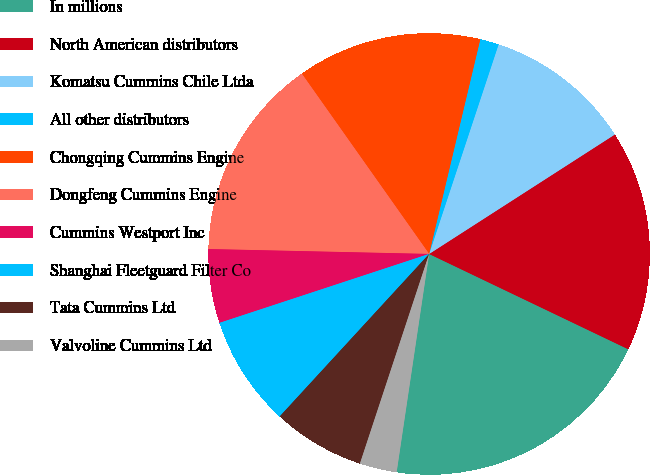Convert chart to OTSL. <chart><loc_0><loc_0><loc_500><loc_500><pie_chart><fcel>In millions<fcel>North American distributors<fcel>Komatsu Cummins Chile Ltda<fcel>All other distributors<fcel>Chongqing Cummins Engine<fcel>Dongfeng Cummins Engine<fcel>Cummins Westport Inc<fcel>Shanghai Fleetguard Filter Co<fcel>Tata Cummins Ltd<fcel>Valvoline Cummins Ltd<nl><fcel>20.25%<fcel>16.2%<fcel>10.81%<fcel>1.37%<fcel>13.51%<fcel>14.86%<fcel>5.41%<fcel>8.11%<fcel>6.76%<fcel>2.72%<nl></chart> 